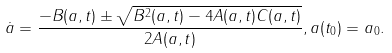Convert formula to latex. <formula><loc_0><loc_0><loc_500><loc_500>\dot { a } = \frac { - B ( a , t ) \pm \sqrt { B ^ { 2 } ( a , t ) - 4 A ( a , t ) C ( a , t ) } } { 2 A ( a , t ) } , a ( t _ { 0 } ) = a _ { 0 } .</formula> 